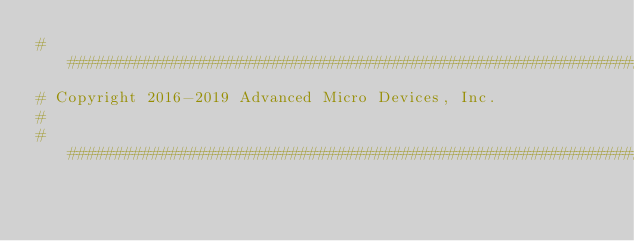<code> <loc_0><loc_0><loc_500><loc_500><_Python_># ########################################################################
# Copyright 2016-2019 Advanced Micro Devices, Inc.
#
# ########################################################################
</code> 